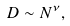<formula> <loc_0><loc_0><loc_500><loc_500>D \sim N ^ { \nu } ,</formula> 